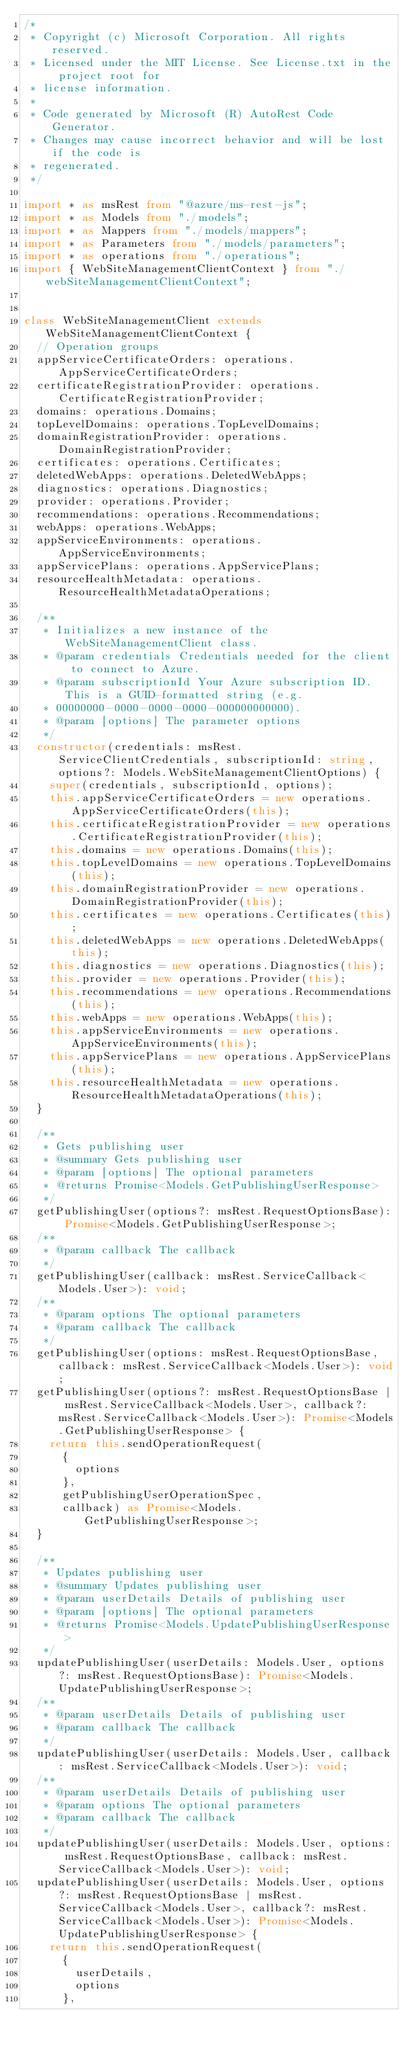Convert code to text. <code><loc_0><loc_0><loc_500><loc_500><_TypeScript_>/*
 * Copyright (c) Microsoft Corporation. All rights reserved.
 * Licensed under the MIT License. See License.txt in the project root for
 * license information.
 *
 * Code generated by Microsoft (R) AutoRest Code Generator.
 * Changes may cause incorrect behavior and will be lost if the code is
 * regenerated.
 */

import * as msRest from "@azure/ms-rest-js";
import * as Models from "./models";
import * as Mappers from "./models/mappers";
import * as Parameters from "./models/parameters";
import * as operations from "./operations";
import { WebSiteManagementClientContext } from "./webSiteManagementClientContext";


class WebSiteManagementClient extends WebSiteManagementClientContext {
  // Operation groups
  appServiceCertificateOrders: operations.AppServiceCertificateOrders;
  certificateRegistrationProvider: operations.CertificateRegistrationProvider;
  domains: operations.Domains;
  topLevelDomains: operations.TopLevelDomains;
  domainRegistrationProvider: operations.DomainRegistrationProvider;
  certificates: operations.Certificates;
  deletedWebApps: operations.DeletedWebApps;
  diagnostics: operations.Diagnostics;
  provider: operations.Provider;
  recommendations: operations.Recommendations;
  webApps: operations.WebApps;
  appServiceEnvironments: operations.AppServiceEnvironments;
  appServicePlans: operations.AppServicePlans;
  resourceHealthMetadata: operations.ResourceHealthMetadataOperations;

  /**
   * Initializes a new instance of the WebSiteManagementClient class.
   * @param credentials Credentials needed for the client to connect to Azure.
   * @param subscriptionId Your Azure subscription ID. This is a GUID-formatted string (e.g.
   * 00000000-0000-0000-0000-000000000000).
   * @param [options] The parameter options
   */
  constructor(credentials: msRest.ServiceClientCredentials, subscriptionId: string, options?: Models.WebSiteManagementClientOptions) {
    super(credentials, subscriptionId, options);
    this.appServiceCertificateOrders = new operations.AppServiceCertificateOrders(this);
    this.certificateRegistrationProvider = new operations.CertificateRegistrationProvider(this);
    this.domains = new operations.Domains(this);
    this.topLevelDomains = new operations.TopLevelDomains(this);
    this.domainRegistrationProvider = new operations.DomainRegistrationProvider(this);
    this.certificates = new operations.Certificates(this);
    this.deletedWebApps = new operations.DeletedWebApps(this);
    this.diagnostics = new operations.Diagnostics(this);
    this.provider = new operations.Provider(this);
    this.recommendations = new operations.Recommendations(this);
    this.webApps = new operations.WebApps(this);
    this.appServiceEnvironments = new operations.AppServiceEnvironments(this);
    this.appServicePlans = new operations.AppServicePlans(this);
    this.resourceHealthMetadata = new operations.ResourceHealthMetadataOperations(this);
  }

  /**
   * Gets publishing user
   * @summary Gets publishing user
   * @param [options] The optional parameters
   * @returns Promise<Models.GetPublishingUserResponse>
   */
  getPublishingUser(options?: msRest.RequestOptionsBase): Promise<Models.GetPublishingUserResponse>;
  /**
   * @param callback The callback
   */
  getPublishingUser(callback: msRest.ServiceCallback<Models.User>): void;
  /**
   * @param options The optional parameters
   * @param callback The callback
   */
  getPublishingUser(options: msRest.RequestOptionsBase, callback: msRest.ServiceCallback<Models.User>): void;
  getPublishingUser(options?: msRest.RequestOptionsBase | msRest.ServiceCallback<Models.User>, callback?: msRest.ServiceCallback<Models.User>): Promise<Models.GetPublishingUserResponse> {
    return this.sendOperationRequest(
      {
        options
      },
      getPublishingUserOperationSpec,
      callback) as Promise<Models.GetPublishingUserResponse>;
  }

  /**
   * Updates publishing user
   * @summary Updates publishing user
   * @param userDetails Details of publishing user
   * @param [options] The optional parameters
   * @returns Promise<Models.UpdatePublishingUserResponse>
   */
  updatePublishingUser(userDetails: Models.User, options?: msRest.RequestOptionsBase): Promise<Models.UpdatePublishingUserResponse>;
  /**
   * @param userDetails Details of publishing user
   * @param callback The callback
   */
  updatePublishingUser(userDetails: Models.User, callback: msRest.ServiceCallback<Models.User>): void;
  /**
   * @param userDetails Details of publishing user
   * @param options The optional parameters
   * @param callback The callback
   */
  updatePublishingUser(userDetails: Models.User, options: msRest.RequestOptionsBase, callback: msRest.ServiceCallback<Models.User>): void;
  updatePublishingUser(userDetails: Models.User, options?: msRest.RequestOptionsBase | msRest.ServiceCallback<Models.User>, callback?: msRest.ServiceCallback<Models.User>): Promise<Models.UpdatePublishingUserResponse> {
    return this.sendOperationRequest(
      {
        userDetails,
        options
      },</code> 